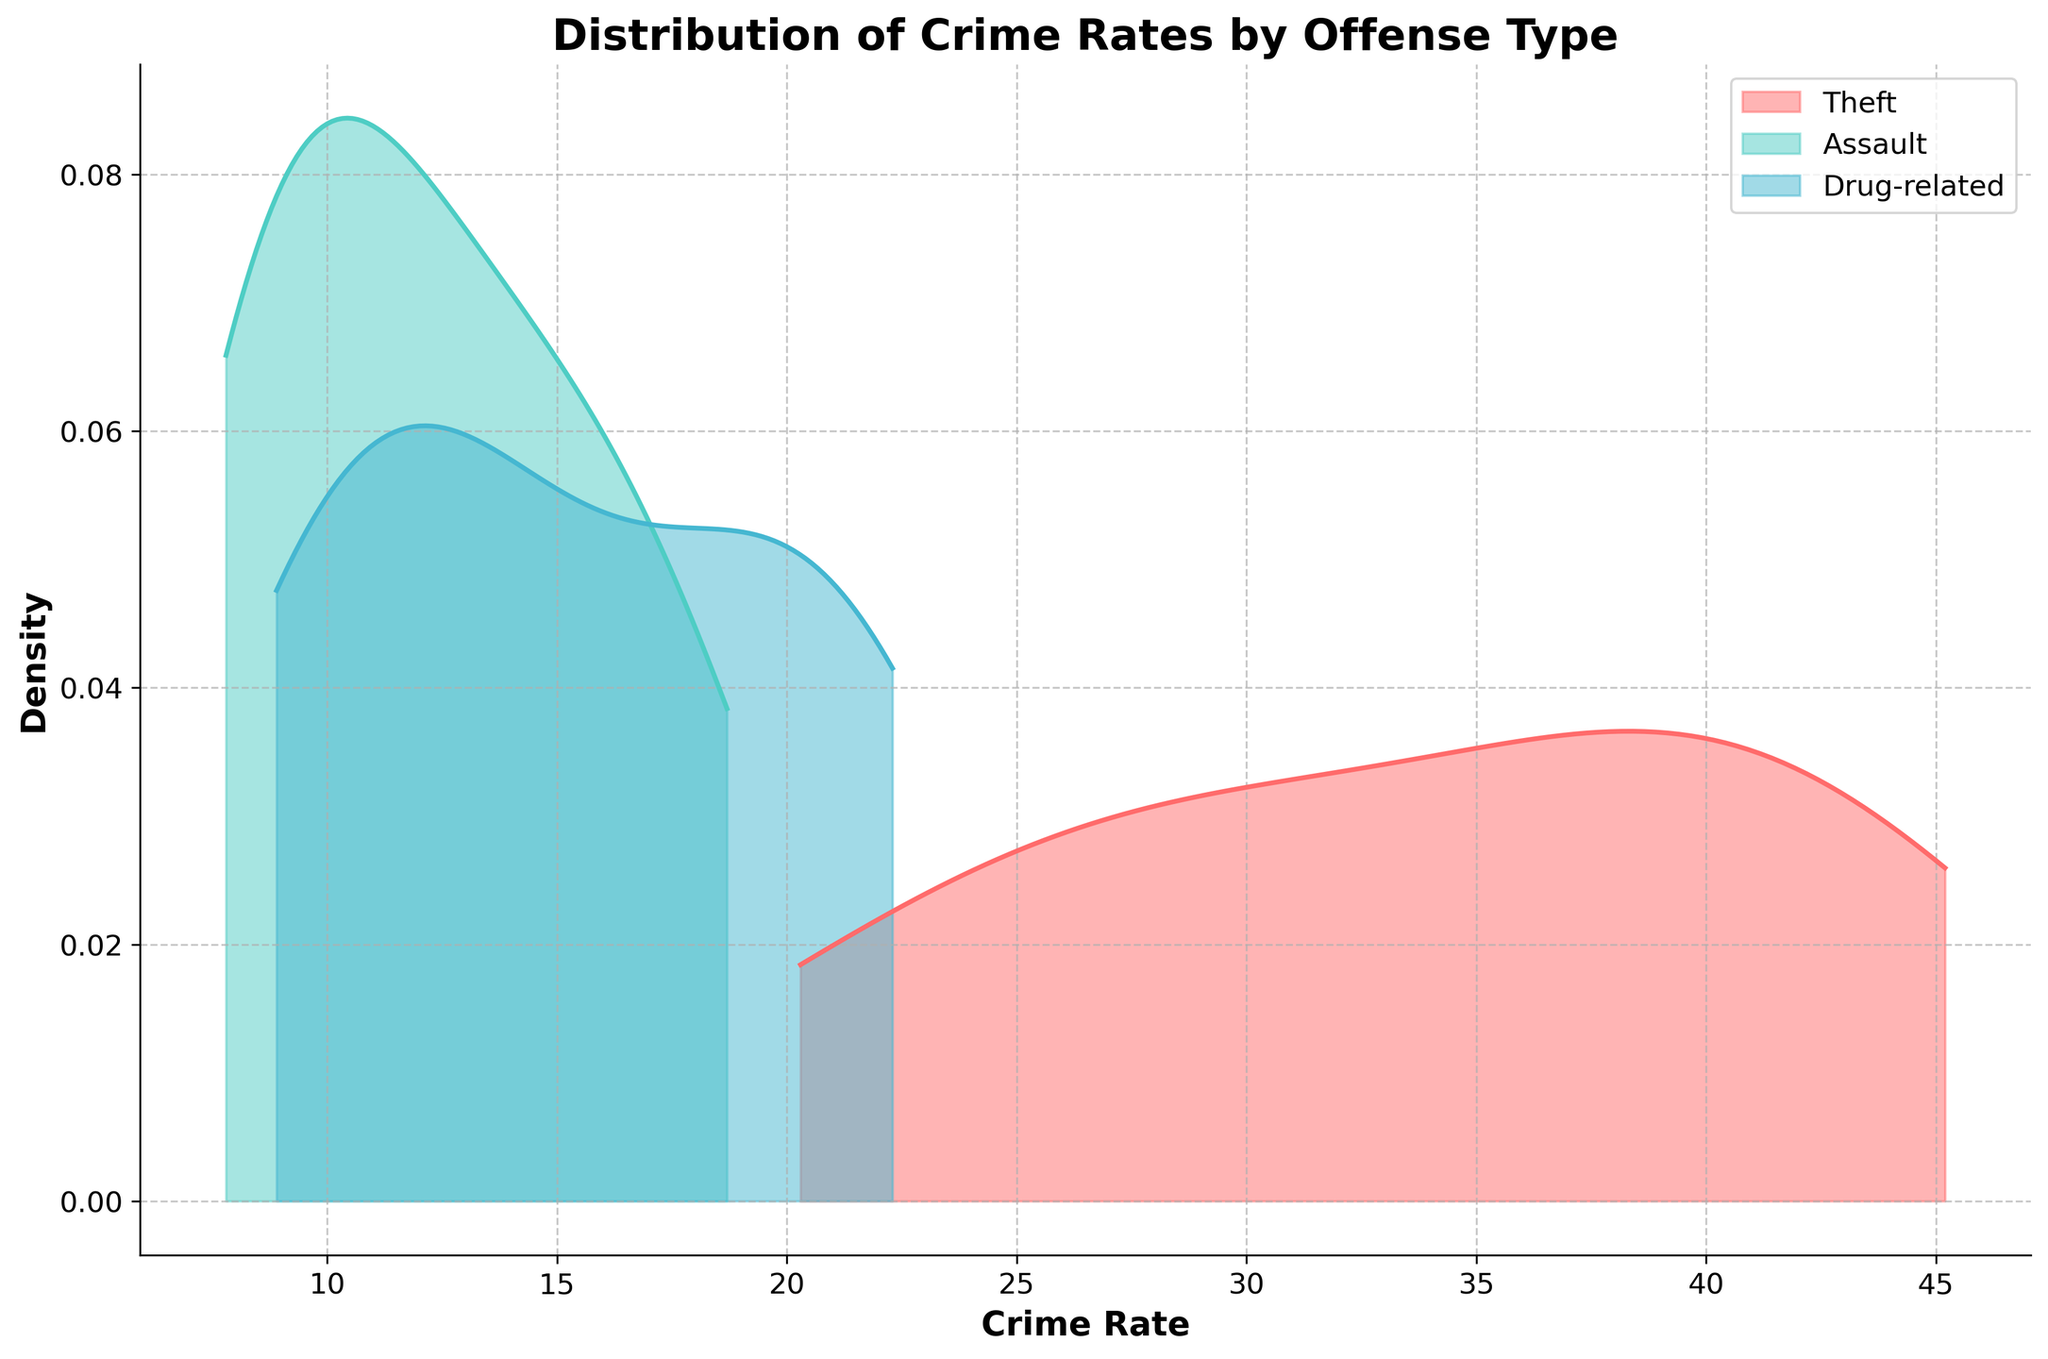What are the axes labels in the plot? The x-axis label is "Crime Rate", while the y-axis label is "Density".
Answer: "Crime Rate" and "Density" Which offense type has the highest peak density? By looking at the density curves, the curve with the highest peak represents the offense with the highest density.
Answer: Theft What's the title of the plot? The title is typically shown at the top of the plot, summarizing the content.
Answer: Distribution of Crime Rates by Offense Type Among the offenses, which one has the broadest spread in crime rate distribution? The offense with the broadest spread will have the widest density curve along the x-axis.
Answer: Theft Does the density curve for "Assault" show multiple peaks? To check for multiple peaks, look for more than one highest point in the density curve.
Answer: No Which offense has the narrowest distribution of crime rates? The narrowest distribution corresponds to the offense with the narrowest spread in its density curve.
Answer: Assault Are there areas where the distributions of different offenses overlap? Overlapping areas can be identified where density curves of different offenses intersect.
Answer: Yes Between "Drug-related" and "Assault", which has a higher crime rate peak density? Compare the peak heights of the two density curves for "Drug-related" and "Assault".
Answer: Drug-related What is the general trend of crime rates for "Theft" offenses compared to others? Examine the position and spread of the density curve for "Theft" relative to other offense types.
Answer: Higher and broader Is the density curve for "Drug-related" offenses skewed to the left or right? Index the curve's asymmetry; a left skew has a longer left tail, while a right skew has a longer right tail.
Answer: Right 